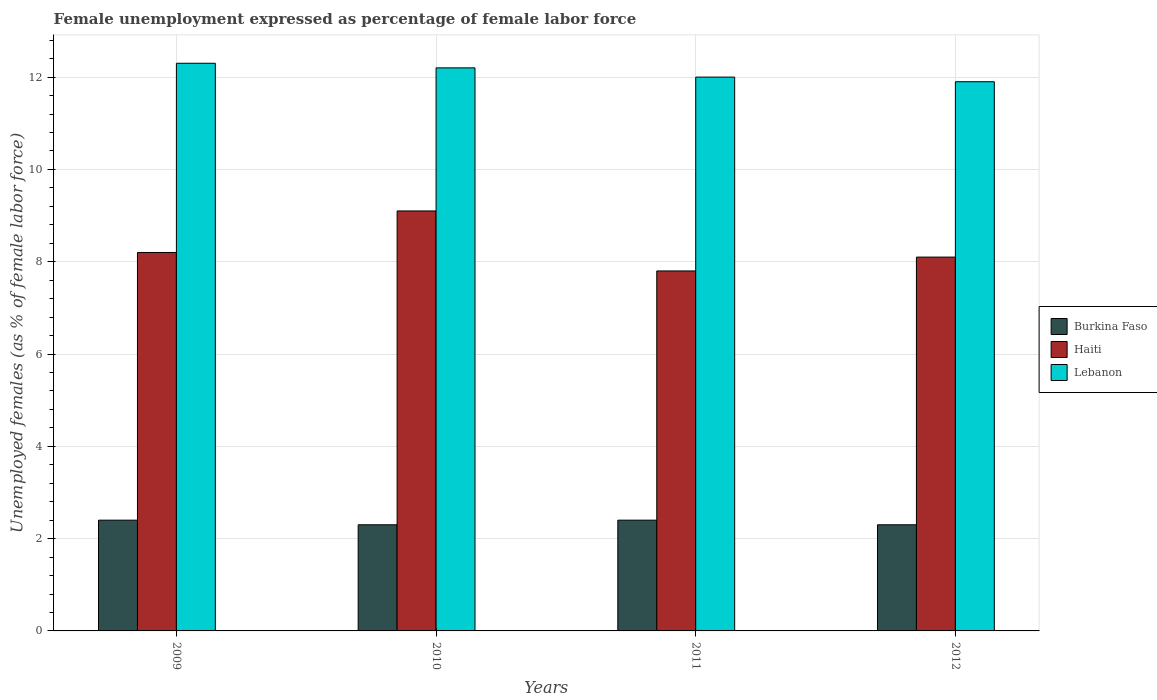How many different coloured bars are there?
Offer a very short reply. 3. How many groups of bars are there?
Your response must be concise. 4. How many bars are there on the 4th tick from the right?
Your response must be concise. 3. In how many cases, is the number of bars for a given year not equal to the number of legend labels?
Ensure brevity in your answer.  0. What is the unemployment in females in in Haiti in 2009?
Provide a short and direct response. 8.2. Across all years, what is the maximum unemployment in females in in Haiti?
Ensure brevity in your answer.  9.1. Across all years, what is the minimum unemployment in females in in Burkina Faso?
Ensure brevity in your answer.  2.3. In which year was the unemployment in females in in Haiti minimum?
Provide a succinct answer. 2011. What is the total unemployment in females in in Haiti in the graph?
Make the answer very short. 33.2. What is the difference between the unemployment in females in in Lebanon in 2009 and that in 2010?
Keep it short and to the point. 0.1. What is the difference between the unemployment in females in in Lebanon in 2009 and the unemployment in females in in Haiti in 2012?
Give a very brief answer. 4.2. What is the average unemployment in females in in Haiti per year?
Your response must be concise. 8.3. In the year 2012, what is the difference between the unemployment in females in in Burkina Faso and unemployment in females in in Lebanon?
Your answer should be very brief. -9.6. In how many years, is the unemployment in females in in Burkina Faso greater than 6 %?
Offer a very short reply. 0. What is the ratio of the unemployment in females in in Haiti in 2011 to that in 2012?
Provide a succinct answer. 0.96. What is the difference between the highest and the second highest unemployment in females in in Lebanon?
Keep it short and to the point. 0.1. What is the difference between the highest and the lowest unemployment in females in in Lebanon?
Your answer should be compact. 0.4. What does the 1st bar from the left in 2012 represents?
Your answer should be very brief. Burkina Faso. What does the 2nd bar from the right in 2012 represents?
Give a very brief answer. Haiti. Are all the bars in the graph horizontal?
Provide a short and direct response. No. How many years are there in the graph?
Provide a succinct answer. 4. What is the difference between two consecutive major ticks on the Y-axis?
Offer a very short reply. 2. Where does the legend appear in the graph?
Your answer should be compact. Center right. How many legend labels are there?
Your response must be concise. 3. What is the title of the graph?
Offer a very short reply. Female unemployment expressed as percentage of female labor force. Does "High income: nonOECD" appear as one of the legend labels in the graph?
Ensure brevity in your answer.  No. What is the label or title of the Y-axis?
Your answer should be compact. Unemployed females (as % of female labor force). What is the Unemployed females (as % of female labor force) in Burkina Faso in 2009?
Your answer should be very brief. 2.4. What is the Unemployed females (as % of female labor force) in Haiti in 2009?
Make the answer very short. 8.2. What is the Unemployed females (as % of female labor force) in Lebanon in 2009?
Ensure brevity in your answer.  12.3. What is the Unemployed females (as % of female labor force) of Burkina Faso in 2010?
Your answer should be very brief. 2.3. What is the Unemployed females (as % of female labor force) of Haiti in 2010?
Your answer should be compact. 9.1. What is the Unemployed females (as % of female labor force) in Lebanon in 2010?
Your answer should be compact. 12.2. What is the Unemployed females (as % of female labor force) of Burkina Faso in 2011?
Your answer should be very brief. 2.4. What is the Unemployed females (as % of female labor force) in Haiti in 2011?
Offer a terse response. 7.8. What is the Unemployed females (as % of female labor force) in Burkina Faso in 2012?
Keep it short and to the point. 2.3. What is the Unemployed females (as % of female labor force) of Haiti in 2012?
Provide a short and direct response. 8.1. What is the Unemployed females (as % of female labor force) of Lebanon in 2012?
Your response must be concise. 11.9. Across all years, what is the maximum Unemployed females (as % of female labor force) of Burkina Faso?
Offer a terse response. 2.4. Across all years, what is the maximum Unemployed females (as % of female labor force) in Haiti?
Provide a short and direct response. 9.1. Across all years, what is the maximum Unemployed females (as % of female labor force) in Lebanon?
Keep it short and to the point. 12.3. Across all years, what is the minimum Unemployed females (as % of female labor force) of Burkina Faso?
Ensure brevity in your answer.  2.3. Across all years, what is the minimum Unemployed females (as % of female labor force) in Haiti?
Provide a succinct answer. 7.8. Across all years, what is the minimum Unemployed females (as % of female labor force) of Lebanon?
Keep it short and to the point. 11.9. What is the total Unemployed females (as % of female labor force) in Burkina Faso in the graph?
Provide a short and direct response. 9.4. What is the total Unemployed females (as % of female labor force) of Haiti in the graph?
Offer a terse response. 33.2. What is the total Unemployed females (as % of female labor force) in Lebanon in the graph?
Your answer should be very brief. 48.4. What is the difference between the Unemployed females (as % of female labor force) in Haiti in 2009 and that in 2011?
Provide a short and direct response. 0.4. What is the difference between the Unemployed females (as % of female labor force) in Haiti in 2009 and that in 2012?
Provide a short and direct response. 0.1. What is the difference between the Unemployed females (as % of female labor force) in Lebanon in 2009 and that in 2012?
Keep it short and to the point. 0.4. What is the difference between the Unemployed females (as % of female labor force) in Burkina Faso in 2010 and that in 2011?
Make the answer very short. -0.1. What is the difference between the Unemployed females (as % of female labor force) in Haiti in 2010 and that in 2011?
Offer a very short reply. 1.3. What is the difference between the Unemployed females (as % of female labor force) in Haiti in 2010 and that in 2012?
Provide a short and direct response. 1. What is the difference between the Unemployed females (as % of female labor force) of Lebanon in 2010 and that in 2012?
Offer a very short reply. 0.3. What is the difference between the Unemployed females (as % of female labor force) of Haiti in 2011 and that in 2012?
Provide a succinct answer. -0.3. What is the difference between the Unemployed females (as % of female labor force) of Burkina Faso in 2009 and the Unemployed females (as % of female labor force) of Haiti in 2010?
Offer a terse response. -6.7. What is the difference between the Unemployed females (as % of female labor force) of Burkina Faso in 2009 and the Unemployed females (as % of female labor force) of Lebanon in 2010?
Provide a succinct answer. -9.8. What is the difference between the Unemployed females (as % of female labor force) in Haiti in 2009 and the Unemployed females (as % of female labor force) in Lebanon in 2010?
Give a very brief answer. -4. What is the difference between the Unemployed females (as % of female labor force) of Burkina Faso in 2009 and the Unemployed females (as % of female labor force) of Lebanon in 2011?
Keep it short and to the point. -9.6. What is the difference between the Unemployed females (as % of female labor force) in Haiti in 2009 and the Unemployed females (as % of female labor force) in Lebanon in 2011?
Make the answer very short. -3.8. What is the difference between the Unemployed females (as % of female labor force) in Burkina Faso in 2009 and the Unemployed females (as % of female labor force) in Lebanon in 2012?
Ensure brevity in your answer.  -9.5. What is the difference between the Unemployed females (as % of female labor force) of Haiti in 2009 and the Unemployed females (as % of female labor force) of Lebanon in 2012?
Your response must be concise. -3.7. What is the difference between the Unemployed females (as % of female labor force) in Burkina Faso in 2010 and the Unemployed females (as % of female labor force) in Haiti in 2011?
Your answer should be compact. -5.5. What is the difference between the Unemployed females (as % of female labor force) in Burkina Faso in 2010 and the Unemployed females (as % of female labor force) in Lebanon in 2011?
Your answer should be compact. -9.7. What is the difference between the Unemployed females (as % of female labor force) of Haiti in 2010 and the Unemployed females (as % of female labor force) of Lebanon in 2011?
Keep it short and to the point. -2.9. What is the difference between the Unemployed females (as % of female labor force) in Burkina Faso in 2010 and the Unemployed females (as % of female labor force) in Haiti in 2012?
Your response must be concise. -5.8. What is the difference between the Unemployed females (as % of female labor force) of Burkina Faso in 2010 and the Unemployed females (as % of female labor force) of Lebanon in 2012?
Your response must be concise. -9.6. What is the difference between the Unemployed females (as % of female labor force) in Burkina Faso in 2011 and the Unemployed females (as % of female labor force) in Haiti in 2012?
Ensure brevity in your answer.  -5.7. What is the difference between the Unemployed females (as % of female labor force) of Haiti in 2011 and the Unemployed females (as % of female labor force) of Lebanon in 2012?
Your response must be concise. -4.1. What is the average Unemployed females (as % of female labor force) in Burkina Faso per year?
Make the answer very short. 2.35. In the year 2009, what is the difference between the Unemployed females (as % of female labor force) of Burkina Faso and Unemployed females (as % of female labor force) of Lebanon?
Your answer should be very brief. -9.9. In the year 2010, what is the difference between the Unemployed females (as % of female labor force) in Burkina Faso and Unemployed females (as % of female labor force) in Haiti?
Offer a very short reply. -6.8. In the year 2010, what is the difference between the Unemployed females (as % of female labor force) of Haiti and Unemployed females (as % of female labor force) of Lebanon?
Your answer should be very brief. -3.1. In the year 2012, what is the difference between the Unemployed females (as % of female labor force) in Burkina Faso and Unemployed females (as % of female labor force) in Haiti?
Your answer should be very brief. -5.8. In the year 2012, what is the difference between the Unemployed females (as % of female labor force) of Burkina Faso and Unemployed females (as % of female labor force) of Lebanon?
Make the answer very short. -9.6. What is the ratio of the Unemployed females (as % of female labor force) in Burkina Faso in 2009 to that in 2010?
Make the answer very short. 1.04. What is the ratio of the Unemployed females (as % of female labor force) in Haiti in 2009 to that in 2010?
Your answer should be very brief. 0.9. What is the ratio of the Unemployed females (as % of female labor force) of Lebanon in 2009 to that in 2010?
Your response must be concise. 1.01. What is the ratio of the Unemployed females (as % of female labor force) of Burkina Faso in 2009 to that in 2011?
Ensure brevity in your answer.  1. What is the ratio of the Unemployed females (as % of female labor force) in Haiti in 2009 to that in 2011?
Your answer should be compact. 1.05. What is the ratio of the Unemployed females (as % of female labor force) of Lebanon in 2009 to that in 2011?
Offer a terse response. 1.02. What is the ratio of the Unemployed females (as % of female labor force) of Burkina Faso in 2009 to that in 2012?
Give a very brief answer. 1.04. What is the ratio of the Unemployed females (as % of female labor force) in Haiti in 2009 to that in 2012?
Ensure brevity in your answer.  1.01. What is the ratio of the Unemployed females (as % of female labor force) of Lebanon in 2009 to that in 2012?
Provide a short and direct response. 1.03. What is the ratio of the Unemployed females (as % of female labor force) in Burkina Faso in 2010 to that in 2011?
Ensure brevity in your answer.  0.96. What is the ratio of the Unemployed females (as % of female labor force) of Haiti in 2010 to that in 2011?
Your response must be concise. 1.17. What is the ratio of the Unemployed females (as % of female labor force) in Lebanon in 2010 to that in 2011?
Provide a succinct answer. 1.02. What is the ratio of the Unemployed females (as % of female labor force) in Burkina Faso in 2010 to that in 2012?
Your response must be concise. 1. What is the ratio of the Unemployed females (as % of female labor force) of Haiti in 2010 to that in 2012?
Offer a terse response. 1.12. What is the ratio of the Unemployed females (as % of female labor force) of Lebanon in 2010 to that in 2012?
Offer a terse response. 1.03. What is the ratio of the Unemployed females (as % of female labor force) of Burkina Faso in 2011 to that in 2012?
Offer a terse response. 1.04. What is the ratio of the Unemployed females (as % of female labor force) of Lebanon in 2011 to that in 2012?
Your answer should be compact. 1.01. What is the difference between the highest and the second highest Unemployed females (as % of female labor force) of Haiti?
Keep it short and to the point. 0.9. What is the difference between the highest and the second highest Unemployed females (as % of female labor force) of Lebanon?
Give a very brief answer. 0.1. What is the difference between the highest and the lowest Unemployed females (as % of female labor force) in Burkina Faso?
Provide a succinct answer. 0.1. What is the difference between the highest and the lowest Unemployed females (as % of female labor force) of Haiti?
Keep it short and to the point. 1.3. 